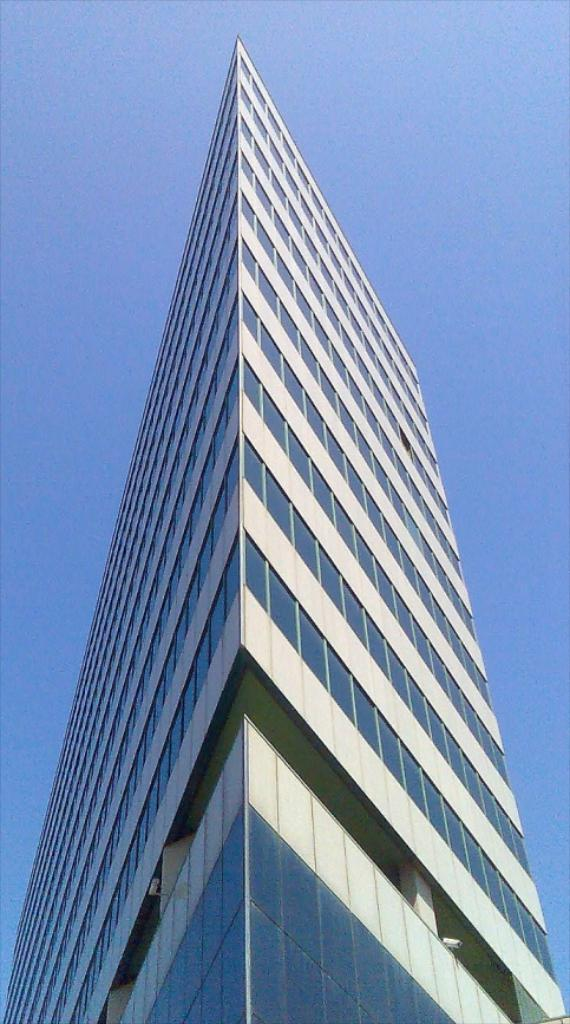What type of structure is present in the image? There is a building in the image. What can be seen in the background of the image? The sky is visible in the background of the image. What type of jeans are the hands wearing in the image? There are no jeans or hands present in the image; it only features a building and the sky. 